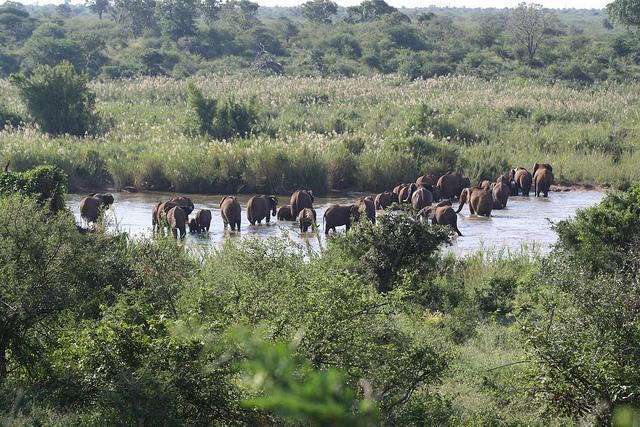How many news anchors are on the television screen?
Give a very brief answer. 0. 